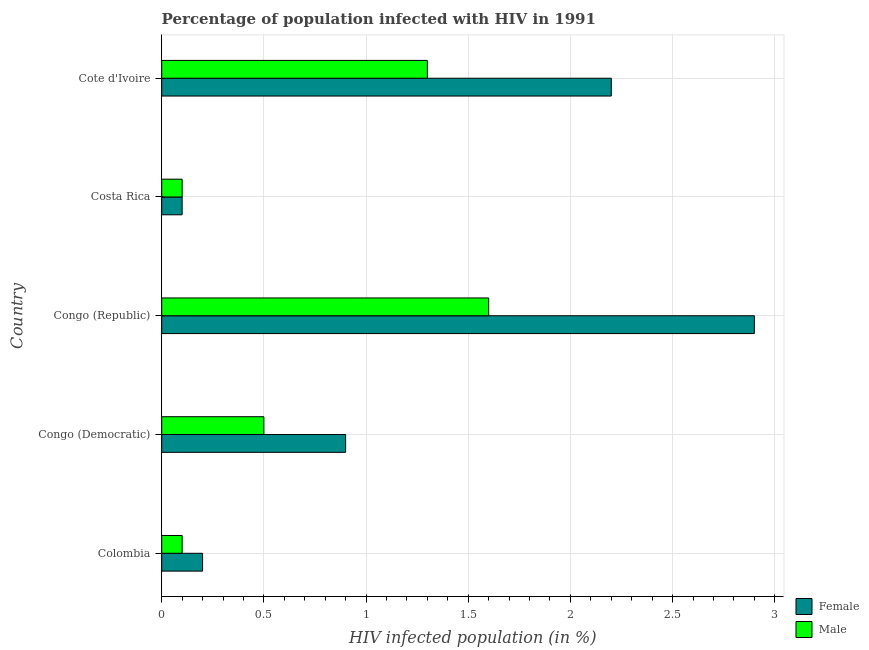How many different coloured bars are there?
Keep it short and to the point. 2. How many bars are there on the 3rd tick from the top?
Offer a very short reply. 2. What is the label of the 4th group of bars from the top?
Your answer should be compact. Congo (Democratic). In how many cases, is the number of bars for a given country not equal to the number of legend labels?
Offer a terse response. 0. Across all countries, what is the maximum percentage of females who are infected with hiv?
Your answer should be very brief. 2.9. Across all countries, what is the minimum percentage of females who are infected with hiv?
Offer a terse response. 0.1. In which country was the percentage of females who are infected with hiv maximum?
Keep it short and to the point. Congo (Republic). What is the total percentage of females who are infected with hiv in the graph?
Provide a short and direct response. 6.3. What is the difference between the percentage of females who are infected with hiv in Costa Rica and the percentage of males who are infected with hiv in Colombia?
Make the answer very short. 0. What is the average percentage of females who are infected with hiv per country?
Your answer should be compact. 1.26. Is the percentage of males who are infected with hiv in Congo (Democratic) less than that in Cote d'Ivoire?
Provide a short and direct response. Yes. In how many countries, is the percentage of females who are infected with hiv greater than the average percentage of females who are infected with hiv taken over all countries?
Your answer should be very brief. 2. Is the sum of the percentage of males who are infected with hiv in Colombia and Cote d'Ivoire greater than the maximum percentage of females who are infected with hiv across all countries?
Your answer should be compact. No. Are all the bars in the graph horizontal?
Offer a very short reply. Yes. How many countries are there in the graph?
Provide a short and direct response. 5. What is the difference between two consecutive major ticks on the X-axis?
Provide a short and direct response. 0.5. Does the graph contain any zero values?
Provide a short and direct response. No. Does the graph contain grids?
Offer a very short reply. Yes. How many legend labels are there?
Ensure brevity in your answer.  2. How are the legend labels stacked?
Provide a short and direct response. Vertical. What is the title of the graph?
Your answer should be compact. Percentage of population infected with HIV in 1991. What is the label or title of the X-axis?
Your response must be concise. HIV infected population (in %). What is the HIV infected population (in %) of Female in Colombia?
Your answer should be very brief. 0.2. What is the HIV infected population (in %) in Male in Colombia?
Give a very brief answer. 0.1. What is the HIV infected population (in %) of Female in Congo (Democratic)?
Offer a terse response. 0.9. What is the HIV infected population (in %) of Female in Costa Rica?
Keep it short and to the point. 0.1. What is the HIV infected population (in %) of Male in Costa Rica?
Offer a very short reply. 0.1. Across all countries, what is the maximum HIV infected population (in %) of Female?
Your response must be concise. 2.9. Across all countries, what is the maximum HIV infected population (in %) of Male?
Your answer should be very brief. 1.6. Across all countries, what is the minimum HIV infected population (in %) in Female?
Ensure brevity in your answer.  0.1. Across all countries, what is the minimum HIV infected population (in %) of Male?
Provide a succinct answer. 0.1. What is the total HIV infected population (in %) in Male in the graph?
Give a very brief answer. 3.6. What is the difference between the HIV infected population (in %) in Female in Colombia and that in Congo (Republic)?
Keep it short and to the point. -2.7. What is the difference between the HIV infected population (in %) of Male in Colombia and that in Congo (Republic)?
Your response must be concise. -1.5. What is the difference between the HIV infected population (in %) of Female in Colombia and that in Costa Rica?
Your answer should be very brief. 0.1. What is the difference between the HIV infected population (in %) in Female in Congo (Democratic) and that in Congo (Republic)?
Ensure brevity in your answer.  -2. What is the difference between the HIV infected population (in %) in Male in Congo (Democratic) and that in Cote d'Ivoire?
Your response must be concise. -0.8. What is the difference between the HIV infected population (in %) of Male in Congo (Republic) and that in Costa Rica?
Offer a terse response. 1.5. What is the difference between the HIV infected population (in %) in Male in Congo (Republic) and that in Cote d'Ivoire?
Your answer should be compact. 0.3. What is the difference between the HIV infected population (in %) of Male in Costa Rica and that in Cote d'Ivoire?
Provide a short and direct response. -1.2. What is the difference between the HIV infected population (in %) of Female in Colombia and the HIV infected population (in %) of Male in Congo (Republic)?
Your response must be concise. -1.4. What is the difference between the HIV infected population (in %) in Female in Colombia and the HIV infected population (in %) in Male in Costa Rica?
Make the answer very short. 0.1. What is the difference between the HIV infected population (in %) in Female in Colombia and the HIV infected population (in %) in Male in Cote d'Ivoire?
Offer a very short reply. -1.1. What is the difference between the HIV infected population (in %) of Female in Congo (Democratic) and the HIV infected population (in %) of Male in Costa Rica?
Provide a succinct answer. 0.8. What is the average HIV infected population (in %) in Female per country?
Make the answer very short. 1.26. What is the average HIV infected population (in %) of Male per country?
Your answer should be very brief. 0.72. What is the difference between the HIV infected population (in %) in Female and HIV infected population (in %) in Male in Congo (Republic)?
Keep it short and to the point. 1.3. What is the difference between the HIV infected population (in %) of Female and HIV infected population (in %) of Male in Costa Rica?
Your answer should be very brief. 0. What is the ratio of the HIV infected population (in %) in Female in Colombia to that in Congo (Democratic)?
Keep it short and to the point. 0.22. What is the ratio of the HIV infected population (in %) in Female in Colombia to that in Congo (Republic)?
Your answer should be very brief. 0.07. What is the ratio of the HIV infected population (in %) of Male in Colombia to that in Congo (Republic)?
Keep it short and to the point. 0.06. What is the ratio of the HIV infected population (in %) in Male in Colombia to that in Costa Rica?
Keep it short and to the point. 1. What is the ratio of the HIV infected population (in %) of Female in Colombia to that in Cote d'Ivoire?
Your answer should be very brief. 0.09. What is the ratio of the HIV infected population (in %) of Male in Colombia to that in Cote d'Ivoire?
Make the answer very short. 0.08. What is the ratio of the HIV infected population (in %) in Female in Congo (Democratic) to that in Congo (Republic)?
Provide a succinct answer. 0.31. What is the ratio of the HIV infected population (in %) in Male in Congo (Democratic) to that in Congo (Republic)?
Offer a terse response. 0.31. What is the ratio of the HIV infected population (in %) of Female in Congo (Democratic) to that in Cote d'Ivoire?
Offer a terse response. 0.41. What is the ratio of the HIV infected population (in %) in Male in Congo (Democratic) to that in Cote d'Ivoire?
Provide a succinct answer. 0.38. What is the ratio of the HIV infected population (in %) of Female in Congo (Republic) to that in Cote d'Ivoire?
Your answer should be compact. 1.32. What is the ratio of the HIV infected population (in %) in Male in Congo (Republic) to that in Cote d'Ivoire?
Make the answer very short. 1.23. What is the ratio of the HIV infected population (in %) in Female in Costa Rica to that in Cote d'Ivoire?
Offer a very short reply. 0.05. What is the ratio of the HIV infected population (in %) of Male in Costa Rica to that in Cote d'Ivoire?
Your answer should be compact. 0.08. What is the difference between the highest and the second highest HIV infected population (in %) in Female?
Your answer should be very brief. 0.7. What is the difference between the highest and the second highest HIV infected population (in %) of Male?
Keep it short and to the point. 0.3. 